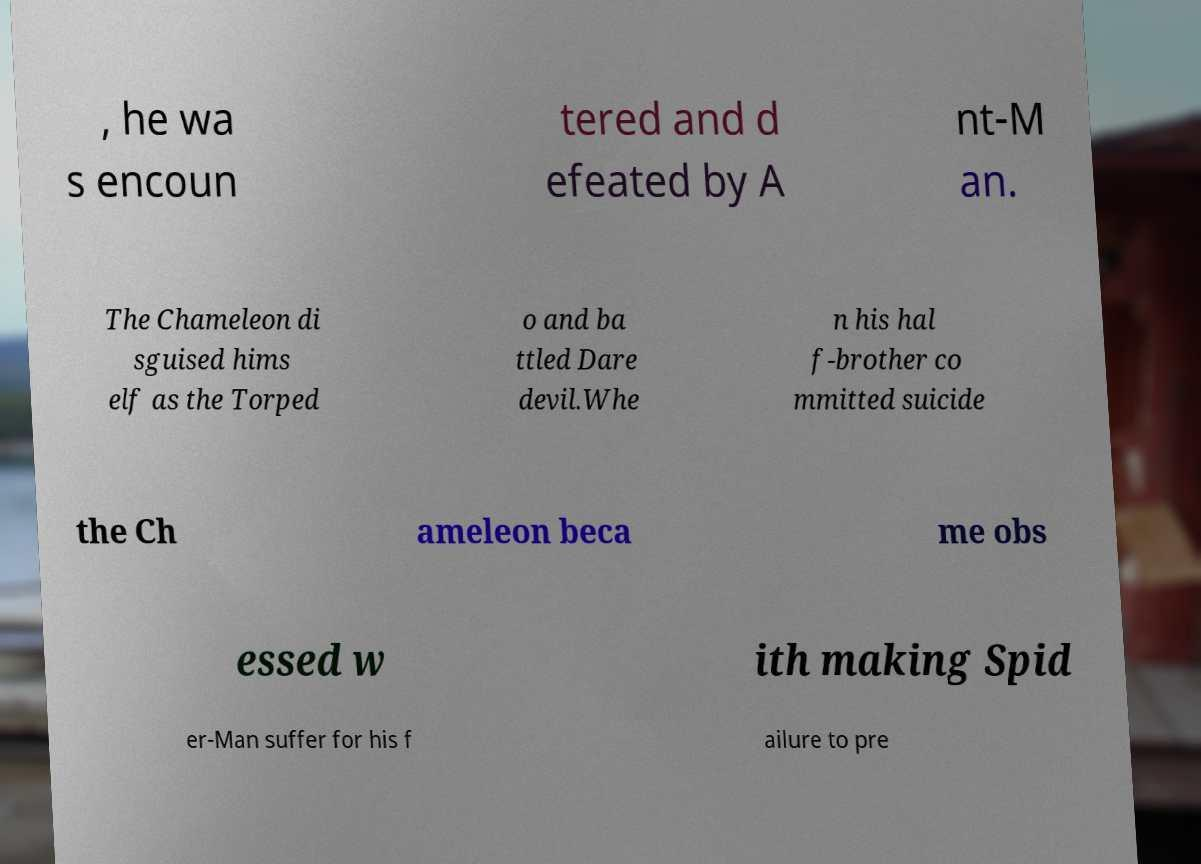Could you assist in decoding the text presented in this image and type it out clearly? , he wa s encoun tered and d efeated by A nt-M an. The Chameleon di sguised hims elf as the Torped o and ba ttled Dare devil.Whe n his hal f-brother co mmitted suicide the Ch ameleon beca me obs essed w ith making Spid er-Man suffer for his f ailure to pre 